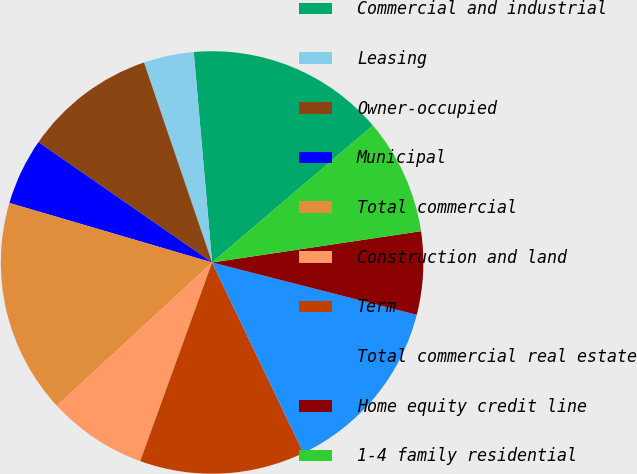<chart> <loc_0><loc_0><loc_500><loc_500><pie_chart><fcel>Commercial and industrial<fcel>Leasing<fcel>Owner-occupied<fcel>Municipal<fcel>Total commercial<fcel>Construction and land<fcel>Term<fcel>Total commercial real estate<fcel>Home equity credit line<fcel>1-4 family residential<nl><fcel>15.15%<fcel>3.84%<fcel>10.13%<fcel>5.1%<fcel>16.41%<fcel>7.61%<fcel>12.64%<fcel>13.9%<fcel>6.35%<fcel>8.87%<nl></chart> 